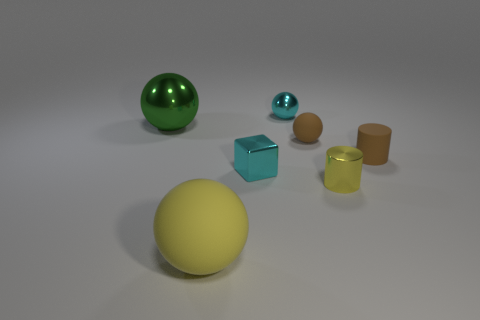Is the color of the rubber cylinder the same as the small matte ball?
Keep it short and to the point. Yes. There is a metal thing that is the same size as the yellow matte thing; what color is it?
Your response must be concise. Green. What number of blue objects are rubber cylinders or big matte blocks?
Make the answer very short. 0. Is the number of tiny shiny balls greater than the number of large gray matte balls?
Ensure brevity in your answer.  Yes. Does the brown object that is left of the small yellow object have the same size as the matte object right of the yellow cylinder?
Offer a terse response. Yes. What is the color of the metallic thing that is to the right of the rubber sphere that is on the right side of the metallic ball on the right side of the cyan metallic block?
Your response must be concise. Yellow. Is there a small brown object that has the same shape as the small yellow object?
Provide a short and direct response. Yes. Is the number of small cyan things that are behind the green shiny thing greater than the number of yellow rubber cylinders?
Offer a very short reply. Yes. How many rubber things are either tiny cyan balls or blocks?
Your answer should be very brief. 0. What is the size of the metal thing that is both behind the small matte ball and to the right of the green object?
Offer a very short reply. Small. 